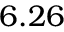Convert formula to latex. <formula><loc_0><loc_0><loc_500><loc_500>6 . 2 6</formula> 